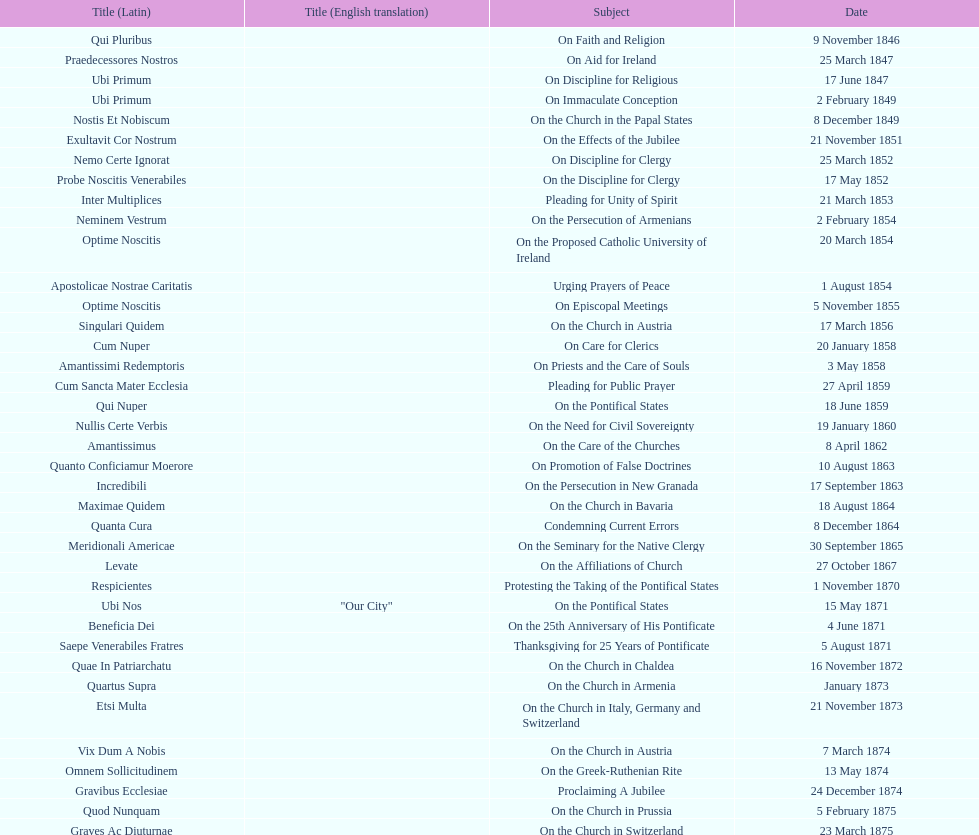What is the sum of all titles? 38. Give me the full table as a dictionary. {'header': ['Title (Latin)', 'Title (English translation)', 'Subject', 'Date'], 'rows': [['Qui Pluribus', '', 'On Faith and Religion', '9 November 1846'], ['Praedecessores Nostros', '', 'On Aid for Ireland', '25 March 1847'], ['Ubi Primum', '', 'On Discipline for Religious', '17 June 1847'], ['Ubi Primum', '', 'On Immaculate Conception', '2 February 1849'], ['Nostis Et Nobiscum', '', 'On the Church in the Papal States', '8 December 1849'], ['Exultavit Cor Nostrum', '', 'On the Effects of the Jubilee', '21 November 1851'], ['Nemo Certe Ignorat', '', 'On Discipline for Clergy', '25 March 1852'], ['Probe Noscitis Venerabiles', '', 'On the Discipline for Clergy', '17 May 1852'], ['Inter Multiplices', '', 'Pleading for Unity of Spirit', '21 March 1853'], ['Neminem Vestrum', '', 'On the Persecution of Armenians', '2 February 1854'], ['Optime Noscitis', '', 'On the Proposed Catholic University of Ireland', '20 March 1854'], ['Apostolicae Nostrae Caritatis', '', 'Urging Prayers of Peace', '1 August 1854'], ['Optime Noscitis', '', 'On Episcopal Meetings', '5 November 1855'], ['Singulari Quidem', '', 'On the Church in Austria', '17 March 1856'], ['Cum Nuper', '', 'On Care for Clerics', '20 January 1858'], ['Amantissimi Redemptoris', '', 'On Priests and the Care of Souls', '3 May 1858'], ['Cum Sancta Mater Ecclesia', '', 'Pleading for Public Prayer', '27 April 1859'], ['Qui Nuper', '', 'On the Pontifical States', '18 June 1859'], ['Nullis Certe Verbis', '', 'On the Need for Civil Sovereignty', '19 January 1860'], ['Amantissimus', '', 'On the Care of the Churches', '8 April 1862'], ['Quanto Conficiamur Moerore', '', 'On Promotion of False Doctrines', '10 August 1863'], ['Incredibili', '', 'On the Persecution in New Granada', '17 September 1863'], ['Maximae Quidem', '', 'On the Church in Bavaria', '18 August 1864'], ['Quanta Cura', '', 'Condemning Current Errors', '8 December 1864'], ['Meridionali Americae', '', 'On the Seminary for the Native Clergy', '30 September 1865'], ['Levate', '', 'On the Affiliations of Church', '27 October 1867'], ['Respicientes', '', 'Protesting the Taking of the Pontifical States', '1 November 1870'], ['Ubi Nos', '"Our City"', 'On the Pontifical States', '15 May 1871'], ['Beneficia Dei', '', 'On the 25th Anniversary of His Pontificate', '4 June 1871'], ['Saepe Venerabiles Fratres', '', 'Thanksgiving for 25 Years of Pontificate', '5 August 1871'], ['Quae In Patriarchatu', '', 'On the Church in Chaldea', '16 November 1872'], ['Quartus Supra', '', 'On the Church in Armenia', 'January 1873'], ['Etsi Multa', '', 'On the Church in Italy, Germany and Switzerland', '21 November 1873'], ['Vix Dum A Nobis', '', 'On the Church in Austria', '7 March 1874'], ['Omnem Sollicitudinem', '', 'On the Greek-Ruthenian Rite', '13 May 1874'], ['Gravibus Ecclesiae', '', 'Proclaiming A Jubilee', '24 December 1874'], ['Quod Nunquam', '', 'On the Church in Prussia', '5 February 1875'], ['Graves Ac Diuturnae', '', 'On the Church in Switzerland', '23 March 1875']]} 